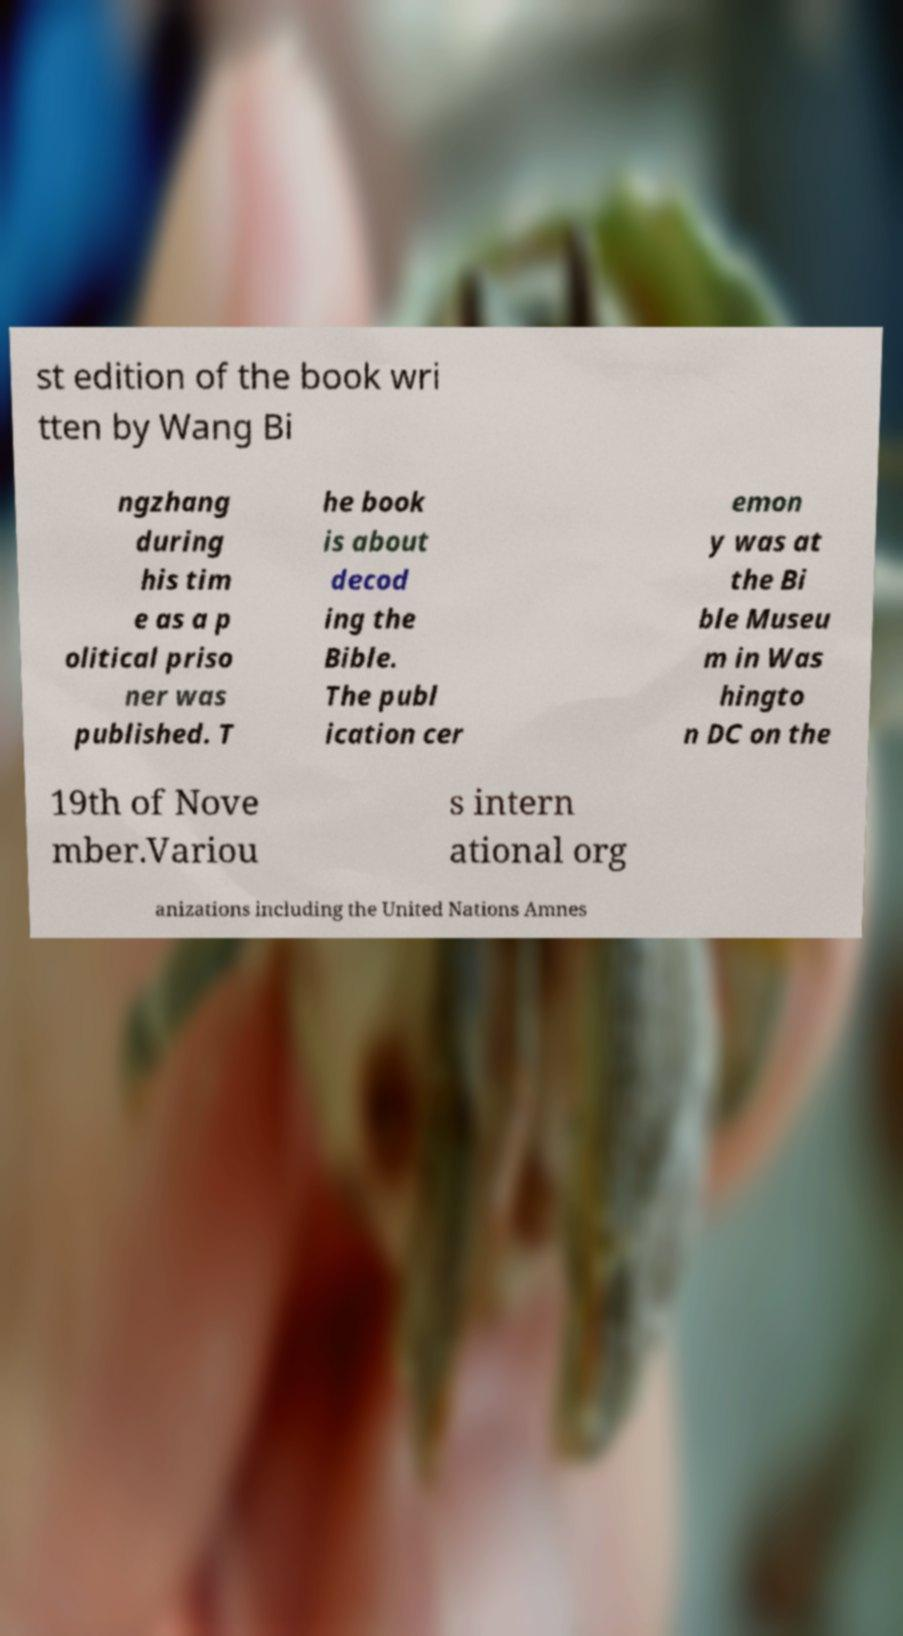Can you read and provide the text displayed in the image?This photo seems to have some interesting text. Can you extract and type it out for me? st edition of the book wri tten by Wang Bi ngzhang during his tim e as a p olitical priso ner was published. T he book is about decod ing the Bible. The publ ication cer emon y was at the Bi ble Museu m in Was hingto n DC on the 19th of Nove mber.Variou s intern ational org anizations including the United Nations Amnes 